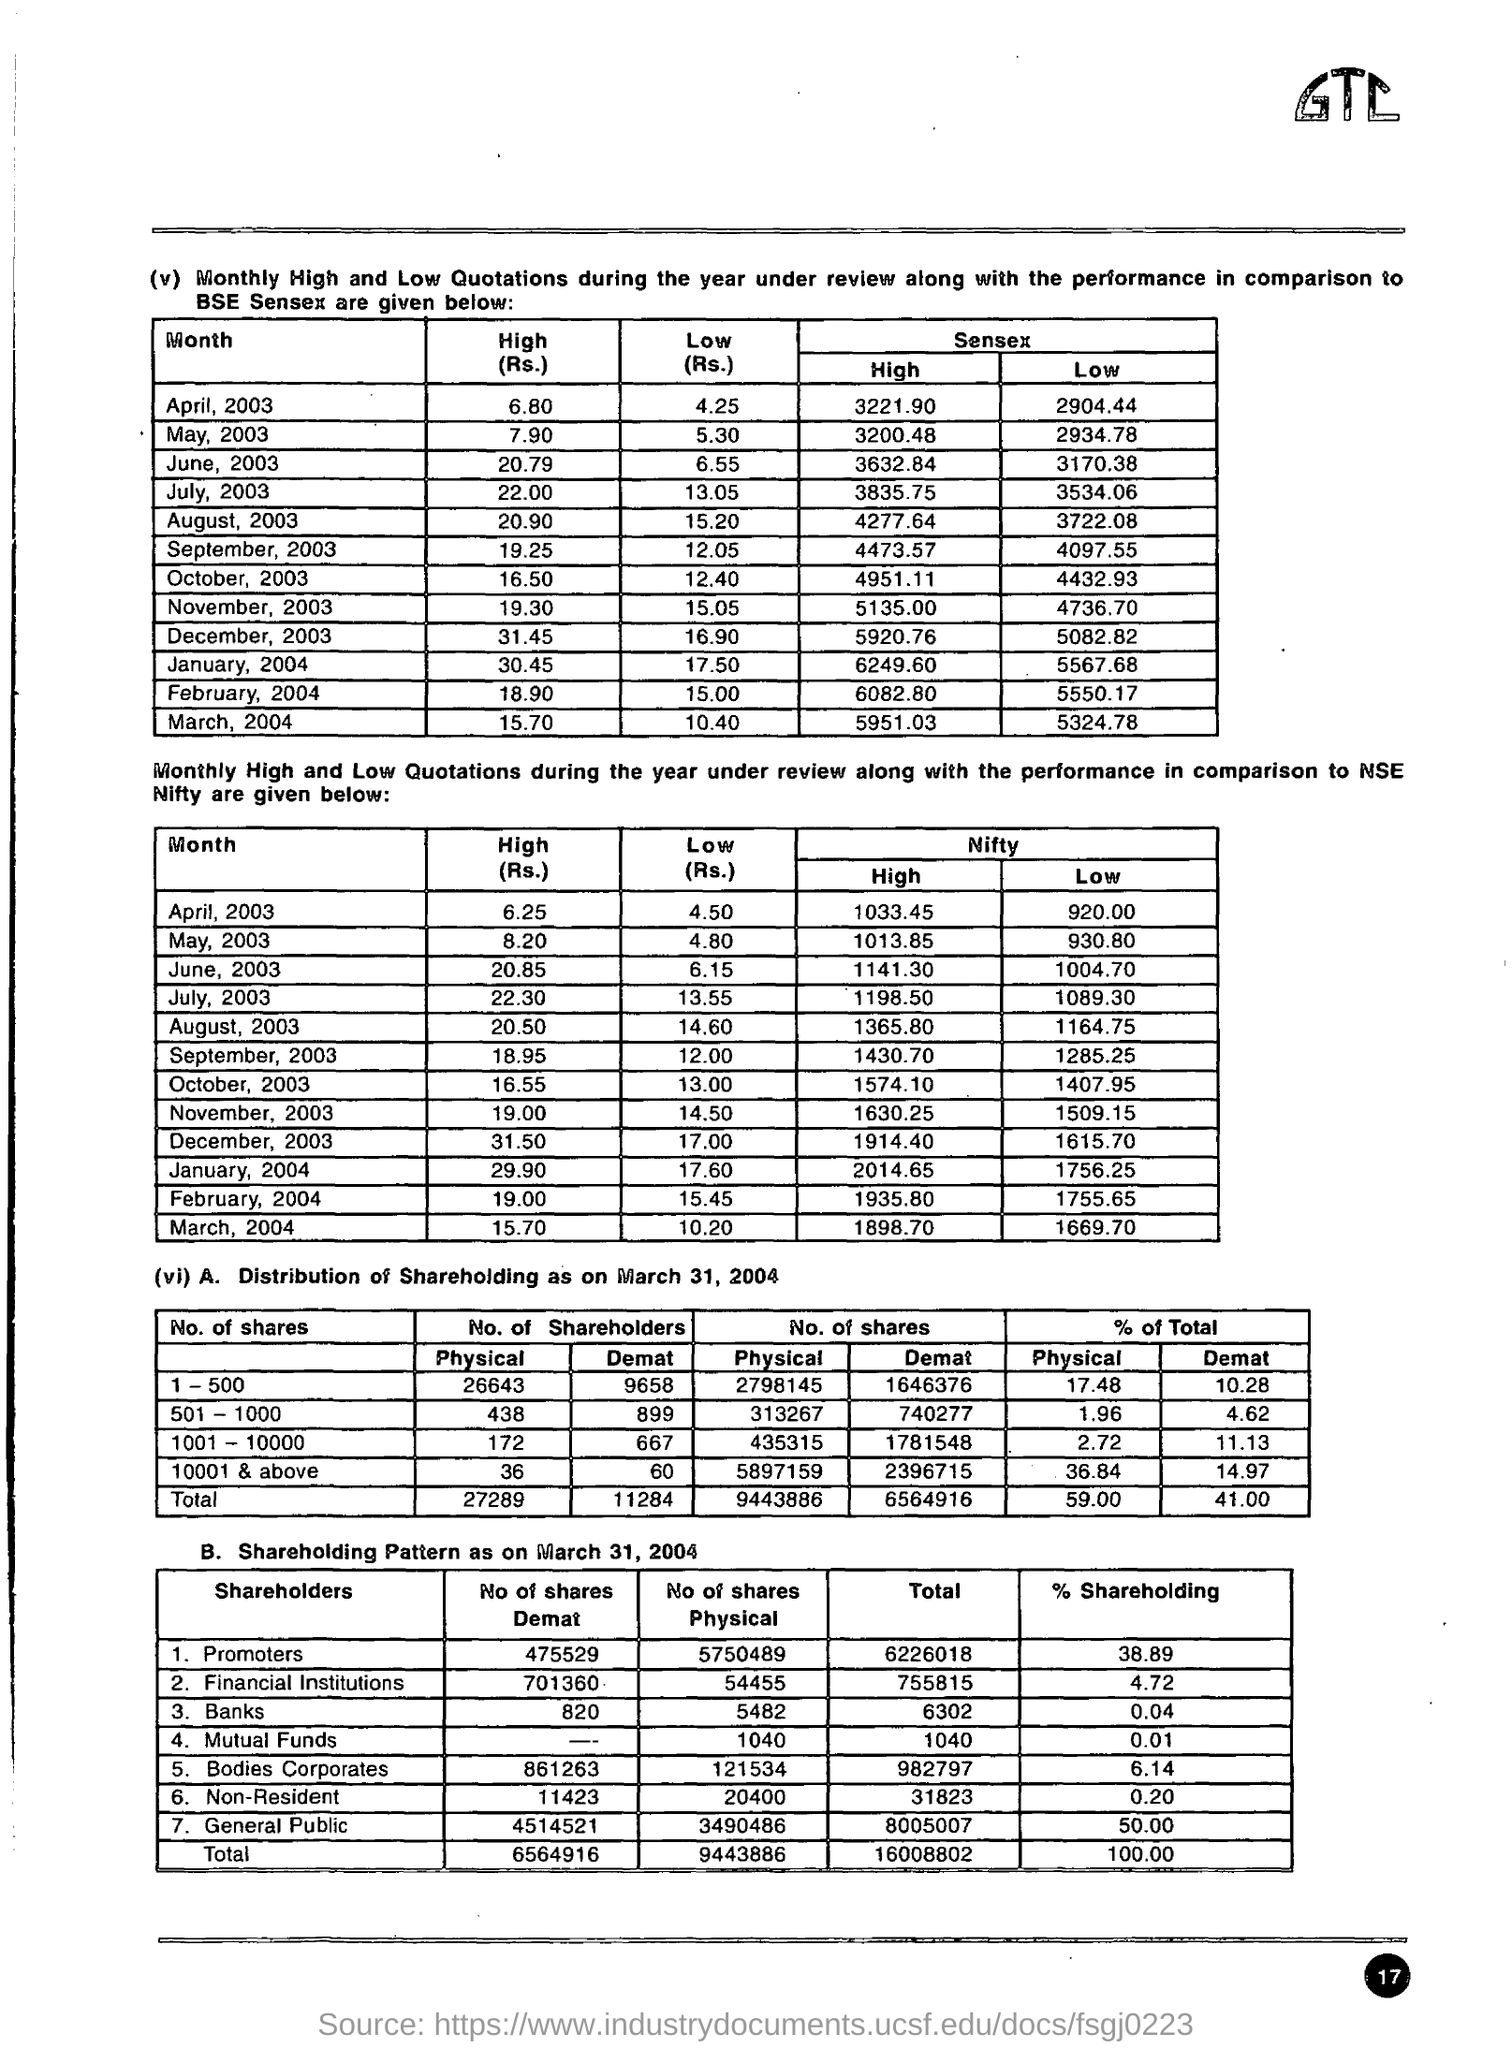What was the high value in BSE Sensex during April 2003?
Offer a very short reply. 3221.90. What was the low value of BSE SENSEX in April 2003?
Your response must be concise. 2904.44. What was the high value in BSE Sensex in May 2003?
Ensure brevity in your answer.  3200.48. What was the low value of BSE SENSEX in May 2003?
Provide a succinct answer. 2934.78. What was the high value in BSE Sensex in June, 2003?
Your answer should be very brief. 3632.84. What was the low value of BSE SENSEX in June,2003??
Provide a short and direct response. 3170.38. What was the high value of BSE SENSEX in July,2003?
Ensure brevity in your answer.  3835.75. What was the low value of BSE  SENSEX in July 2003?
Make the answer very short. 3534.06. What was the high value of BSE SENSEX in aug 2003?
Provide a succinct answer. 4277.64. What was the low value of BSE SENSEX in Aug 2003?
Your answer should be very brief. 3722.08. 